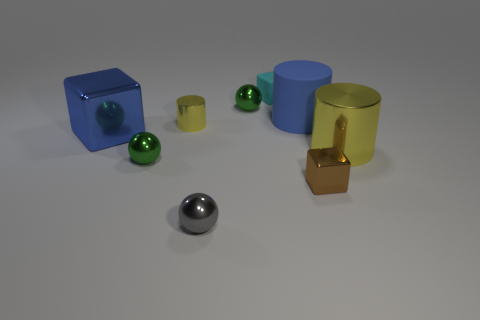There is another metallic cylinder that is the same color as the big metal cylinder; what is its size?
Provide a short and direct response. Small. What shape is the other thing that is the same color as the big rubber thing?
Offer a very short reply. Cube. Does the cyan cube have the same size as the brown shiny block?
Your response must be concise. Yes. There is a block to the left of the green ball on the left side of the tiny gray thing; are there any cyan rubber blocks that are on the left side of it?
Provide a succinct answer. No. What is the size of the blue metal thing?
Offer a very short reply. Large. How many other blue shiny blocks are the same size as the blue block?
Provide a succinct answer. 0. There is another tiny thing that is the same shape as the brown object; what is its material?
Provide a succinct answer. Rubber. What shape is the small object that is in front of the small rubber cube and behind the big blue rubber thing?
Offer a terse response. Sphere. What shape is the large shiny thing that is on the left side of the big blue rubber object?
Make the answer very short. Cube. What number of yellow cylinders are both behind the blue shiny object and to the right of the big rubber object?
Keep it short and to the point. 0. 